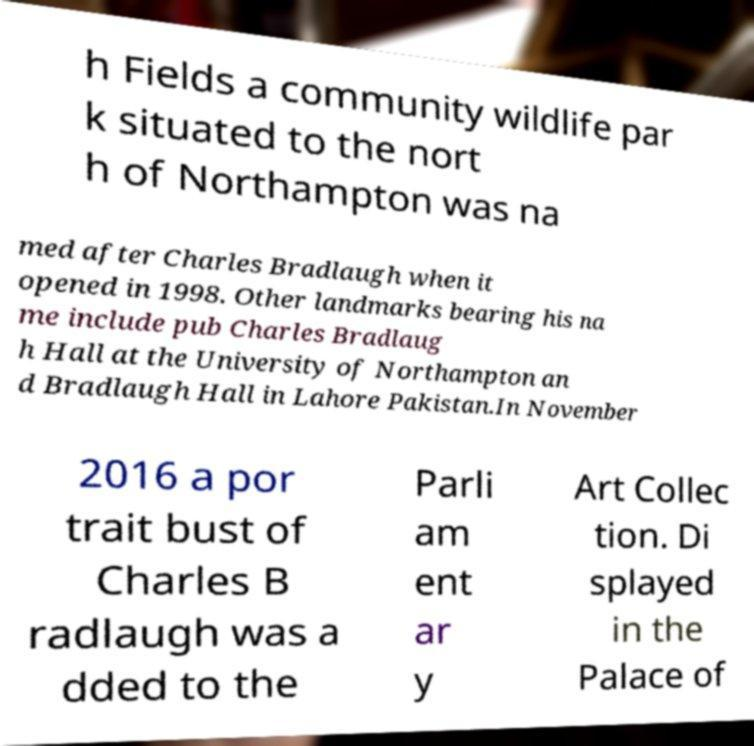For documentation purposes, I need the text within this image transcribed. Could you provide that? h Fields a community wildlife par k situated to the nort h of Northampton was na med after Charles Bradlaugh when it opened in 1998. Other landmarks bearing his na me include pub Charles Bradlaug h Hall at the University of Northampton an d Bradlaugh Hall in Lahore Pakistan.In November 2016 a por trait bust of Charles B radlaugh was a dded to the Parli am ent ar y Art Collec tion. Di splayed in the Palace of 